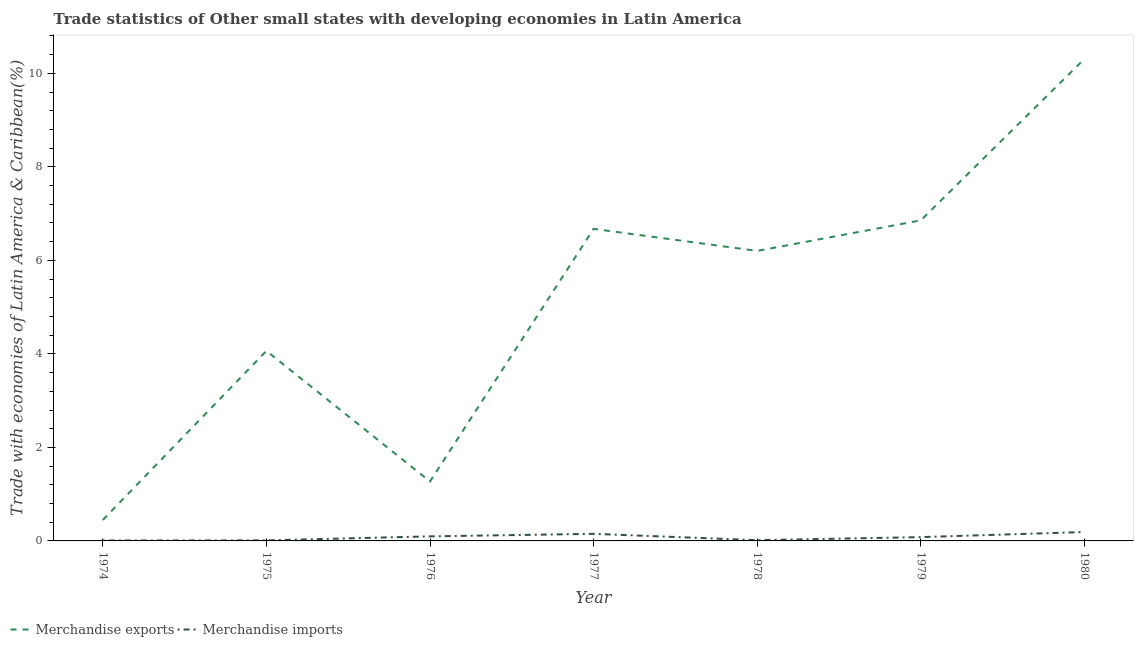Is the number of lines equal to the number of legend labels?
Offer a very short reply. Yes. What is the merchandise imports in 1979?
Your answer should be compact. 0.08. Across all years, what is the maximum merchandise exports?
Ensure brevity in your answer.  10.31. Across all years, what is the minimum merchandise exports?
Your response must be concise. 0.45. In which year was the merchandise imports minimum?
Offer a terse response. 1974. What is the total merchandise imports in the graph?
Give a very brief answer. 0.56. What is the difference between the merchandise exports in 1977 and that in 1980?
Provide a short and direct response. -3.63. What is the difference between the merchandise imports in 1976 and the merchandise exports in 1978?
Your answer should be very brief. -6.1. What is the average merchandise imports per year?
Offer a very short reply. 0.08. In the year 1974, what is the difference between the merchandise exports and merchandise imports?
Your answer should be very brief. 0.44. What is the ratio of the merchandise imports in 1975 to that in 1977?
Your answer should be compact. 0.08. Is the merchandise imports in 1974 less than that in 1976?
Your answer should be compact. Yes. Is the difference between the merchandise imports in 1974 and 1975 greater than the difference between the merchandise exports in 1974 and 1975?
Your response must be concise. Yes. What is the difference between the highest and the second highest merchandise exports?
Offer a very short reply. 3.45. What is the difference between the highest and the lowest merchandise exports?
Your answer should be compact. 9.86. In how many years, is the merchandise exports greater than the average merchandise exports taken over all years?
Offer a very short reply. 4. Is the sum of the merchandise exports in 1975 and 1978 greater than the maximum merchandise imports across all years?
Your answer should be compact. Yes. Does the merchandise imports monotonically increase over the years?
Ensure brevity in your answer.  No. Is the merchandise exports strictly less than the merchandise imports over the years?
Give a very brief answer. No. Are the values on the major ticks of Y-axis written in scientific E-notation?
Provide a short and direct response. No. Does the graph contain any zero values?
Give a very brief answer. No. Where does the legend appear in the graph?
Offer a very short reply. Bottom left. How many legend labels are there?
Provide a short and direct response. 2. What is the title of the graph?
Give a very brief answer. Trade statistics of Other small states with developing economies in Latin America. What is the label or title of the X-axis?
Offer a very short reply. Year. What is the label or title of the Y-axis?
Your answer should be compact. Trade with economies of Latin America & Caribbean(%). What is the Trade with economies of Latin America & Caribbean(%) in Merchandise exports in 1974?
Keep it short and to the point. 0.45. What is the Trade with economies of Latin America & Caribbean(%) of Merchandise imports in 1974?
Your answer should be very brief. 0.01. What is the Trade with economies of Latin America & Caribbean(%) of Merchandise exports in 1975?
Your answer should be very brief. 4.06. What is the Trade with economies of Latin America & Caribbean(%) of Merchandise imports in 1975?
Your response must be concise. 0.01. What is the Trade with economies of Latin America & Caribbean(%) of Merchandise exports in 1976?
Your answer should be very brief. 1.27. What is the Trade with economies of Latin America & Caribbean(%) of Merchandise imports in 1976?
Ensure brevity in your answer.  0.1. What is the Trade with economies of Latin America & Caribbean(%) of Merchandise exports in 1977?
Keep it short and to the point. 6.67. What is the Trade with economies of Latin America & Caribbean(%) in Merchandise imports in 1977?
Provide a short and direct response. 0.15. What is the Trade with economies of Latin America & Caribbean(%) of Merchandise exports in 1978?
Offer a very short reply. 6.2. What is the Trade with economies of Latin America & Caribbean(%) of Merchandise imports in 1978?
Make the answer very short. 0.02. What is the Trade with economies of Latin America & Caribbean(%) of Merchandise exports in 1979?
Keep it short and to the point. 6.86. What is the Trade with economies of Latin America & Caribbean(%) of Merchandise imports in 1979?
Your answer should be very brief. 0.08. What is the Trade with economies of Latin America & Caribbean(%) of Merchandise exports in 1980?
Your answer should be compact. 10.31. What is the Trade with economies of Latin America & Caribbean(%) in Merchandise imports in 1980?
Offer a terse response. 0.19. Across all years, what is the maximum Trade with economies of Latin America & Caribbean(%) of Merchandise exports?
Provide a succinct answer. 10.31. Across all years, what is the maximum Trade with economies of Latin America & Caribbean(%) in Merchandise imports?
Ensure brevity in your answer.  0.19. Across all years, what is the minimum Trade with economies of Latin America & Caribbean(%) of Merchandise exports?
Keep it short and to the point. 0.45. Across all years, what is the minimum Trade with economies of Latin America & Caribbean(%) of Merchandise imports?
Offer a terse response. 0.01. What is the total Trade with economies of Latin America & Caribbean(%) in Merchandise exports in the graph?
Your answer should be compact. 35.82. What is the total Trade with economies of Latin America & Caribbean(%) in Merchandise imports in the graph?
Offer a very short reply. 0.56. What is the difference between the Trade with economies of Latin America & Caribbean(%) in Merchandise exports in 1974 and that in 1975?
Provide a short and direct response. -3.62. What is the difference between the Trade with economies of Latin America & Caribbean(%) of Merchandise imports in 1974 and that in 1975?
Provide a short and direct response. -0. What is the difference between the Trade with economies of Latin America & Caribbean(%) of Merchandise exports in 1974 and that in 1976?
Your answer should be compact. -0.82. What is the difference between the Trade with economies of Latin America & Caribbean(%) in Merchandise imports in 1974 and that in 1976?
Provide a short and direct response. -0.09. What is the difference between the Trade with economies of Latin America & Caribbean(%) of Merchandise exports in 1974 and that in 1977?
Provide a succinct answer. -6.23. What is the difference between the Trade with economies of Latin America & Caribbean(%) of Merchandise imports in 1974 and that in 1977?
Offer a very short reply. -0.14. What is the difference between the Trade with economies of Latin America & Caribbean(%) in Merchandise exports in 1974 and that in 1978?
Ensure brevity in your answer.  -5.75. What is the difference between the Trade with economies of Latin America & Caribbean(%) in Merchandise imports in 1974 and that in 1978?
Your response must be concise. -0.01. What is the difference between the Trade with economies of Latin America & Caribbean(%) in Merchandise exports in 1974 and that in 1979?
Offer a very short reply. -6.41. What is the difference between the Trade with economies of Latin America & Caribbean(%) in Merchandise imports in 1974 and that in 1979?
Make the answer very short. -0.07. What is the difference between the Trade with economies of Latin America & Caribbean(%) in Merchandise exports in 1974 and that in 1980?
Your response must be concise. -9.86. What is the difference between the Trade with economies of Latin America & Caribbean(%) in Merchandise imports in 1974 and that in 1980?
Your response must be concise. -0.18. What is the difference between the Trade with economies of Latin America & Caribbean(%) of Merchandise exports in 1975 and that in 1976?
Your answer should be very brief. 2.79. What is the difference between the Trade with economies of Latin America & Caribbean(%) of Merchandise imports in 1975 and that in 1976?
Offer a terse response. -0.09. What is the difference between the Trade with economies of Latin America & Caribbean(%) of Merchandise exports in 1975 and that in 1977?
Your answer should be compact. -2.61. What is the difference between the Trade with economies of Latin America & Caribbean(%) of Merchandise imports in 1975 and that in 1977?
Give a very brief answer. -0.14. What is the difference between the Trade with economies of Latin America & Caribbean(%) of Merchandise exports in 1975 and that in 1978?
Provide a succinct answer. -2.14. What is the difference between the Trade with economies of Latin America & Caribbean(%) of Merchandise imports in 1975 and that in 1978?
Your answer should be compact. -0. What is the difference between the Trade with economies of Latin America & Caribbean(%) in Merchandise exports in 1975 and that in 1979?
Your answer should be compact. -2.79. What is the difference between the Trade with economies of Latin America & Caribbean(%) of Merchandise imports in 1975 and that in 1979?
Offer a terse response. -0.07. What is the difference between the Trade with economies of Latin America & Caribbean(%) of Merchandise exports in 1975 and that in 1980?
Offer a terse response. -6.24. What is the difference between the Trade with economies of Latin America & Caribbean(%) of Merchandise imports in 1975 and that in 1980?
Provide a short and direct response. -0.18. What is the difference between the Trade with economies of Latin America & Caribbean(%) in Merchandise exports in 1976 and that in 1977?
Offer a very short reply. -5.4. What is the difference between the Trade with economies of Latin America & Caribbean(%) of Merchandise imports in 1976 and that in 1977?
Keep it short and to the point. -0.05. What is the difference between the Trade with economies of Latin America & Caribbean(%) in Merchandise exports in 1976 and that in 1978?
Make the answer very short. -4.93. What is the difference between the Trade with economies of Latin America & Caribbean(%) of Merchandise imports in 1976 and that in 1978?
Offer a terse response. 0.08. What is the difference between the Trade with economies of Latin America & Caribbean(%) of Merchandise exports in 1976 and that in 1979?
Your response must be concise. -5.58. What is the difference between the Trade with economies of Latin America & Caribbean(%) of Merchandise imports in 1976 and that in 1979?
Offer a very short reply. 0.02. What is the difference between the Trade with economies of Latin America & Caribbean(%) of Merchandise exports in 1976 and that in 1980?
Provide a short and direct response. -9.04. What is the difference between the Trade with economies of Latin America & Caribbean(%) of Merchandise imports in 1976 and that in 1980?
Give a very brief answer. -0.09. What is the difference between the Trade with economies of Latin America & Caribbean(%) of Merchandise exports in 1977 and that in 1978?
Provide a succinct answer. 0.47. What is the difference between the Trade with economies of Latin America & Caribbean(%) of Merchandise imports in 1977 and that in 1978?
Offer a terse response. 0.14. What is the difference between the Trade with economies of Latin America & Caribbean(%) in Merchandise exports in 1977 and that in 1979?
Offer a very short reply. -0.18. What is the difference between the Trade with economies of Latin America & Caribbean(%) in Merchandise imports in 1977 and that in 1979?
Give a very brief answer. 0.07. What is the difference between the Trade with economies of Latin America & Caribbean(%) in Merchandise exports in 1977 and that in 1980?
Offer a terse response. -3.63. What is the difference between the Trade with economies of Latin America & Caribbean(%) in Merchandise imports in 1977 and that in 1980?
Provide a succinct answer. -0.04. What is the difference between the Trade with economies of Latin America & Caribbean(%) in Merchandise exports in 1978 and that in 1979?
Provide a succinct answer. -0.65. What is the difference between the Trade with economies of Latin America & Caribbean(%) of Merchandise imports in 1978 and that in 1979?
Ensure brevity in your answer.  -0.07. What is the difference between the Trade with economies of Latin America & Caribbean(%) in Merchandise exports in 1978 and that in 1980?
Provide a short and direct response. -4.11. What is the difference between the Trade with economies of Latin America & Caribbean(%) in Merchandise imports in 1978 and that in 1980?
Make the answer very short. -0.17. What is the difference between the Trade with economies of Latin America & Caribbean(%) in Merchandise exports in 1979 and that in 1980?
Make the answer very short. -3.45. What is the difference between the Trade with economies of Latin America & Caribbean(%) of Merchandise imports in 1979 and that in 1980?
Your response must be concise. -0.11. What is the difference between the Trade with economies of Latin America & Caribbean(%) in Merchandise exports in 1974 and the Trade with economies of Latin America & Caribbean(%) in Merchandise imports in 1975?
Give a very brief answer. 0.44. What is the difference between the Trade with economies of Latin America & Caribbean(%) of Merchandise exports in 1974 and the Trade with economies of Latin America & Caribbean(%) of Merchandise imports in 1976?
Your answer should be very brief. 0.35. What is the difference between the Trade with economies of Latin America & Caribbean(%) in Merchandise exports in 1974 and the Trade with economies of Latin America & Caribbean(%) in Merchandise imports in 1977?
Your answer should be compact. 0.3. What is the difference between the Trade with economies of Latin America & Caribbean(%) in Merchandise exports in 1974 and the Trade with economies of Latin America & Caribbean(%) in Merchandise imports in 1978?
Offer a very short reply. 0.43. What is the difference between the Trade with economies of Latin America & Caribbean(%) in Merchandise exports in 1974 and the Trade with economies of Latin America & Caribbean(%) in Merchandise imports in 1979?
Give a very brief answer. 0.37. What is the difference between the Trade with economies of Latin America & Caribbean(%) in Merchandise exports in 1974 and the Trade with economies of Latin America & Caribbean(%) in Merchandise imports in 1980?
Your response must be concise. 0.26. What is the difference between the Trade with economies of Latin America & Caribbean(%) of Merchandise exports in 1975 and the Trade with economies of Latin America & Caribbean(%) of Merchandise imports in 1976?
Provide a short and direct response. 3.97. What is the difference between the Trade with economies of Latin America & Caribbean(%) of Merchandise exports in 1975 and the Trade with economies of Latin America & Caribbean(%) of Merchandise imports in 1977?
Offer a terse response. 3.91. What is the difference between the Trade with economies of Latin America & Caribbean(%) of Merchandise exports in 1975 and the Trade with economies of Latin America & Caribbean(%) of Merchandise imports in 1978?
Make the answer very short. 4.05. What is the difference between the Trade with economies of Latin America & Caribbean(%) of Merchandise exports in 1975 and the Trade with economies of Latin America & Caribbean(%) of Merchandise imports in 1979?
Ensure brevity in your answer.  3.98. What is the difference between the Trade with economies of Latin America & Caribbean(%) of Merchandise exports in 1975 and the Trade with economies of Latin America & Caribbean(%) of Merchandise imports in 1980?
Offer a very short reply. 3.87. What is the difference between the Trade with economies of Latin America & Caribbean(%) of Merchandise exports in 1976 and the Trade with economies of Latin America & Caribbean(%) of Merchandise imports in 1977?
Your answer should be very brief. 1.12. What is the difference between the Trade with economies of Latin America & Caribbean(%) in Merchandise exports in 1976 and the Trade with economies of Latin America & Caribbean(%) in Merchandise imports in 1978?
Your response must be concise. 1.26. What is the difference between the Trade with economies of Latin America & Caribbean(%) in Merchandise exports in 1976 and the Trade with economies of Latin America & Caribbean(%) in Merchandise imports in 1979?
Offer a very short reply. 1.19. What is the difference between the Trade with economies of Latin America & Caribbean(%) of Merchandise exports in 1976 and the Trade with economies of Latin America & Caribbean(%) of Merchandise imports in 1980?
Give a very brief answer. 1.08. What is the difference between the Trade with economies of Latin America & Caribbean(%) in Merchandise exports in 1977 and the Trade with economies of Latin America & Caribbean(%) in Merchandise imports in 1978?
Ensure brevity in your answer.  6.66. What is the difference between the Trade with economies of Latin America & Caribbean(%) in Merchandise exports in 1977 and the Trade with economies of Latin America & Caribbean(%) in Merchandise imports in 1979?
Give a very brief answer. 6.59. What is the difference between the Trade with economies of Latin America & Caribbean(%) in Merchandise exports in 1977 and the Trade with economies of Latin America & Caribbean(%) in Merchandise imports in 1980?
Keep it short and to the point. 6.48. What is the difference between the Trade with economies of Latin America & Caribbean(%) in Merchandise exports in 1978 and the Trade with economies of Latin America & Caribbean(%) in Merchandise imports in 1979?
Give a very brief answer. 6.12. What is the difference between the Trade with economies of Latin America & Caribbean(%) in Merchandise exports in 1978 and the Trade with economies of Latin America & Caribbean(%) in Merchandise imports in 1980?
Offer a terse response. 6.01. What is the difference between the Trade with economies of Latin America & Caribbean(%) of Merchandise exports in 1979 and the Trade with economies of Latin America & Caribbean(%) of Merchandise imports in 1980?
Provide a short and direct response. 6.67. What is the average Trade with economies of Latin America & Caribbean(%) of Merchandise exports per year?
Your response must be concise. 5.12. What is the average Trade with economies of Latin America & Caribbean(%) in Merchandise imports per year?
Keep it short and to the point. 0.08. In the year 1974, what is the difference between the Trade with economies of Latin America & Caribbean(%) in Merchandise exports and Trade with economies of Latin America & Caribbean(%) in Merchandise imports?
Give a very brief answer. 0.44. In the year 1975, what is the difference between the Trade with economies of Latin America & Caribbean(%) of Merchandise exports and Trade with economies of Latin America & Caribbean(%) of Merchandise imports?
Make the answer very short. 4.05. In the year 1976, what is the difference between the Trade with economies of Latin America & Caribbean(%) of Merchandise exports and Trade with economies of Latin America & Caribbean(%) of Merchandise imports?
Your answer should be compact. 1.17. In the year 1977, what is the difference between the Trade with economies of Latin America & Caribbean(%) in Merchandise exports and Trade with economies of Latin America & Caribbean(%) in Merchandise imports?
Your answer should be very brief. 6.52. In the year 1978, what is the difference between the Trade with economies of Latin America & Caribbean(%) in Merchandise exports and Trade with economies of Latin America & Caribbean(%) in Merchandise imports?
Your answer should be compact. 6.19. In the year 1979, what is the difference between the Trade with economies of Latin America & Caribbean(%) of Merchandise exports and Trade with economies of Latin America & Caribbean(%) of Merchandise imports?
Offer a terse response. 6.77. In the year 1980, what is the difference between the Trade with economies of Latin America & Caribbean(%) of Merchandise exports and Trade with economies of Latin America & Caribbean(%) of Merchandise imports?
Keep it short and to the point. 10.12. What is the ratio of the Trade with economies of Latin America & Caribbean(%) of Merchandise exports in 1974 to that in 1975?
Your answer should be compact. 0.11. What is the ratio of the Trade with economies of Latin America & Caribbean(%) of Merchandise imports in 1974 to that in 1975?
Offer a very short reply. 0.77. What is the ratio of the Trade with economies of Latin America & Caribbean(%) in Merchandise exports in 1974 to that in 1976?
Your answer should be very brief. 0.35. What is the ratio of the Trade with economies of Latin America & Caribbean(%) of Merchandise imports in 1974 to that in 1976?
Provide a short and direct response. 0.09. What is the ratio of the Trade with economies of Latin America & Caribbean(%) of Merchandise exports in 1974 to that in 1977?
Keep it short and to the point. 0.07. What is the ratio of the Trade with economies of Latin America & Caribbean(%) in Merchandise imports in 1974 to that in 1977?
Your answer should be very brief. 0.06. What is the ratio of the Trade with economies of Latin America & Caribbean(%) of Merchandise exports in 1974 to that in 1978?
Your answer should be compact. 0.07. What is the ratio of the Trade with economies of Latin America & Caribbean(%) in Merchandise imports in 1974 to that in 1978?
Provide a succinct answer. 0.56. What is the ratio of the Trade with economies of Latin America & Caribbean(%) of Merchandise exports in 1974 to that in 1979?
Make the answer very short. 0.07. What is the ratio of the Trade with economies of Latin America & Caribbean(%) of Merchandise imports in 1974 to that in 1979?
Offer a terse response. 0.11. What is the ratio of the Trade with economies of Latin America & Caribbean(%) in Merchandise exports in 1974 to that in 1980?
Your answer should be very brief. 0.04. What is the ratio of the Trade with economies of Latin America & Caribbean(%) in Merchandise imports in 1974 to that in 1980?
Give a very brief answer. 0.05. What is the ratio of the Trade with economies of Latin America & Caribbean(%) in Merchandise exports in 1975 to that in 1976?
Your response must be concise. 3.2. What is the ratio of the Trade with economies of Latin America & Caribbean(%) of Merchandise imports in 1975 to that in 1976?
Provide a short and direct response. 0.12. What is the ratio of the Trade with economies of Latin America & Caribbean(%) in Merchandise exports in 1975 to that in 1977?
Ensure brevity in your answer.  0.61. What is the ratio of the Trade with economies of Latin America & Caribbean(%) of Merchandise imports in 1975 to that in 1977?
Ensure brevity in your answer.  0.08. What is the ratio of the Trade with economies of Latin America & Caribbean(%) of Merchandise exports in 1975 to that in 1978?
Your answer should be very brief. 0.66. What is the ratio of the Trade with economies of Latin America & Caribbean(%) of Merchandise imports in 1975 to that in 1978?
Provide a short and direct response. 0.73. What is the ratio of the Trade with economies of Latin America & Caribbean(%) of Merchandise exports in 1975 to that in 1979?
Provide a short and direct response. 0.59. What is the ratio of the Trade with economies of Latin America & Caribbean(%) in Merchandise imports in 1975 to that in 1979?
Offer a terse response. 0.14. What is the ratio of the Trade with economies of Latin America & Caribbean(%) of Merchandise exports in 1975 to that in 1980?
Keep it short and to the point. 0.39. What is the ratio of the Trade with economies of Latin America & Caribbean(%) in Merchandise imports in 1975 to that in 1980?
Your response must be concise. 0.06. What is the ratio of the Trade with economies of Latin America & Caribbean(%) in Merchandise exports in 1976 to that in 1977?
Provide a short and direct response. 0.19. What is the ratio of the Trade with economies of Latin America & Caribbean(%) of Merchandise imports in 1976 to that in 1977?
Give a very brief answer. 0.64. What is the ratio of the Trade with economies of Latin America & Caribbean(%) of Merchandise exports in 1976 to that in 1978?
Keep it short and to the point. 0.2. What is the ratio of the Trade with economies of Latin America & Caribbean(%) of Merchandise imports in 1976 to that in 1978?
Provide a succinct answer. 6.14. What is the ratio of the Trade with economies of Latin America & Caribbean(%) in Merchandise exports in 1976 to that in 1979?
Provide a succinct answer. 0.19. What is the ratio of the Trade with economies of Latin America & Caribbean(%) of Merchandise imports in 1976 to that in 1979?
Keep it short and to the point. 1.2. What is the ratio of the Trade with economies of Latin America & Caribbean(%) of Merchandise exports in 1976 to that in 1980?
Offer a terse response. 0.12. What is the ratio of the Trade with economies of Latin America & Caribbean(%) of Merchandise imports in 1976 to that in 1980?
Your answer should be compact. 0.51. What is the ratio of the Trade with economies of Latin America & Caribbean(%) in Merchandise exports in 1977 to that in 1978?
Give a very brief answer. 1.08. What is the ratio of the Trade with economies of Latin America & Caribbean(%) of Merchandise imports in 1977 to that in 1978?
Keep it short and to the point. 9.55. What is the ratio of the Trade with economies of Latin America & Caribbean(%) in Merchandise exports in 1977 to that in 1979?
Give a very brief answer. 0.97. What is the ratio of the Trade with economies of Latin America & Caribbean(%) in Merchandise imports in 1977 to that in 1979?
Keep it short and to the point. 1.87. What is the ratio of the Trade with economies of Latin America & Caribbean(%) of Merchandise exports in 1977 to that in 1980?
Provide a succinct answer. 0.65. What is the ratio of the Trade with economies of Latin America & Caribbean(%) of Merchandise imports in 1977 to that in 1980?
Ensure brevity in your answer.  0.8. What is the ratio of the Trade with economies of Latin America & Caribbean(%) of Merchandise exports in 1978 to that in 1979?
Offer a terse response. 0.9. What is the ratio of the Trade with economies of Latin America & Caribbean(%) of Merchandise imports in 1978 to that in 1979?
Ensure brevity in your answer.  0.2. What is the ratio of the Trade with economies of Latin America & Caribbean(%) of Merchandise exports in 1978 to that in 1980?
Make the answer very short. 0.6. What is the ratio of the Trade with economies of Latin America & Caribbean(%) of Merchandise imports in 1978 to that in 1980?
Offer a very short reply. 0.08. What is the ratio of the Trade with economies of Latin America & Caribbean(%) of Merchandise exports in 1979 to that in 1980?
Keep it short and to the point. 0.67. What is the ratio of the Trade with economies of Latin America & Caribbean(%) of Merchandise imports in 1979 to that in 1980?
Offer a very short reply. 0.43. What is the difference between the highest and the second highest Trade with economies of Latin America & Caribbean(%) of Merchandise exports?
Ensure brevity in your answer.  3.45. What is the difference between the highest and the second highest Trade with economies of Latin America & Caribbean(%) in Merchandise imports?
Offer a terse response. 0.04. What is the difference between the highest and the lowest Trade with economies of Latin America & Caribbean(%) of Merchandise exports?
Provide a short and direct response. 9.86. What is the difference between the highest and the lowest Trade with economies of Latin America & Caribbean(%) in Merchandise imports?
Your answer should be very brief. 0.18. 